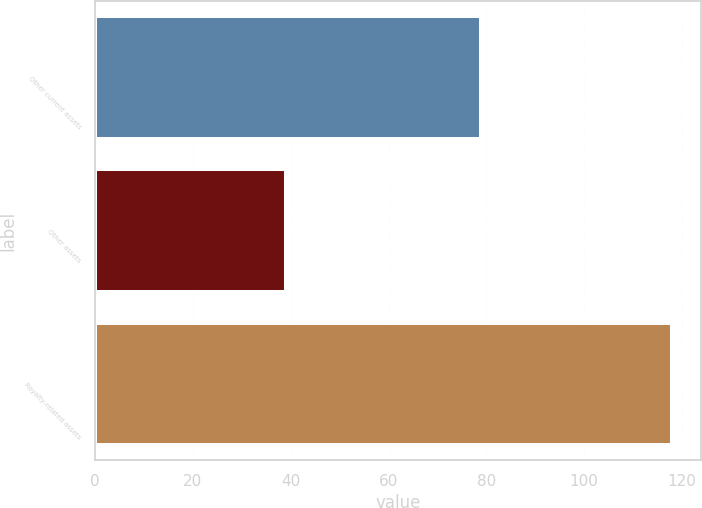Convert chart to OTSL. <chart><loc_0><loc_0><loc_500><loc_500><bar_chart><fcel>Other current assets<fcel>Other assets<fcel>Royalty-related assets<nl><fcel>79<fcel>39<fcel>118<nl></chart> 